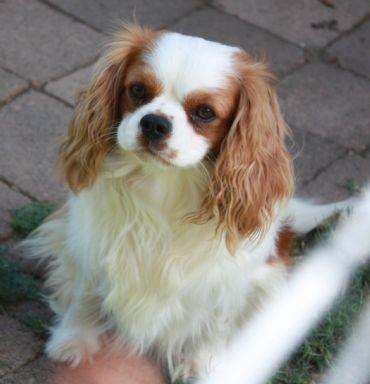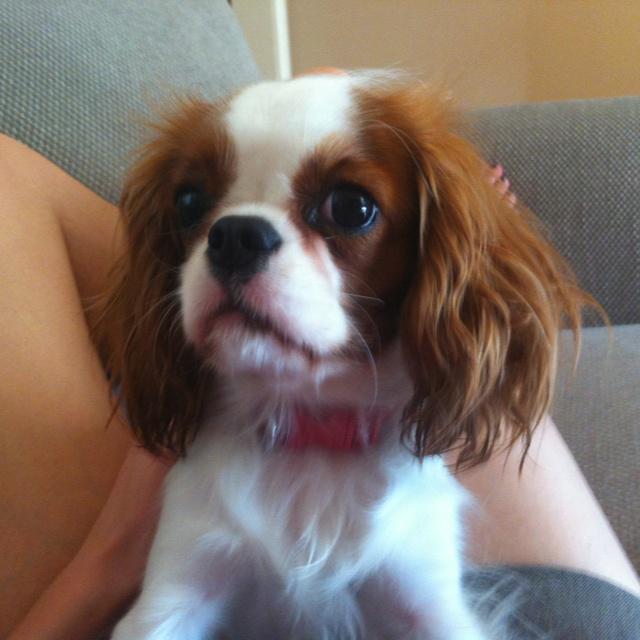The first image is the image on the left, the second image is the image on the right. Evaluate the accuracy of this statement regarding the images: "There is a total of 1 collar on a small dog.". Is it true? Answer yes or no. Yes. 